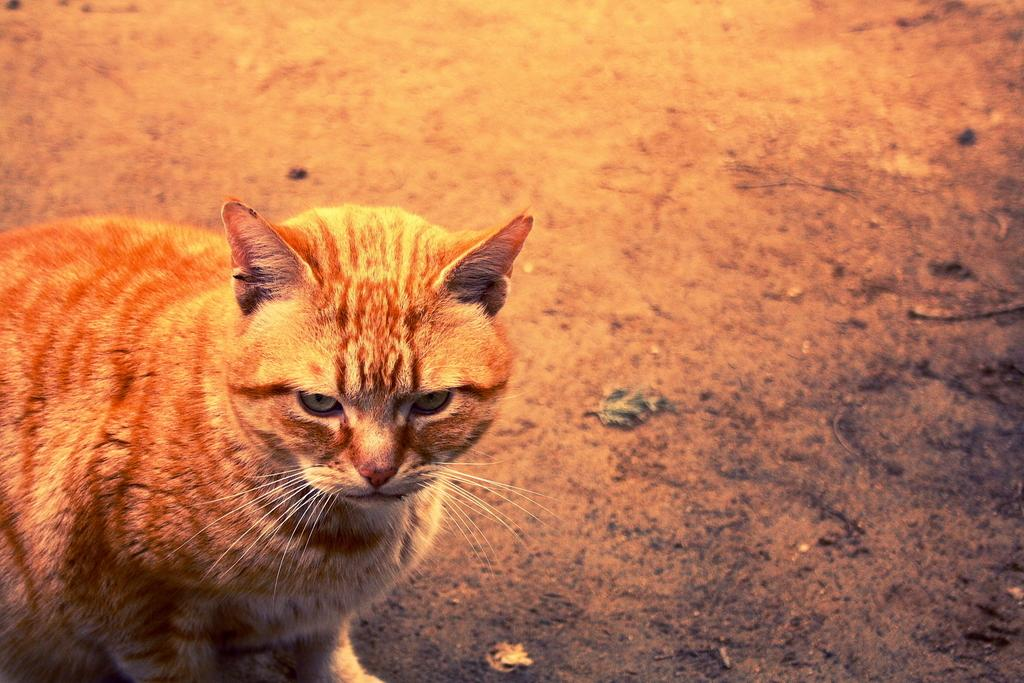What type of animal is present in the image? There is a cat in the image. Where is the cat located in the image? The cat is on the ground. What color is the crayon that the cat is holding in the image? There is no crayon present in the image, and the cat is not holding anything. 